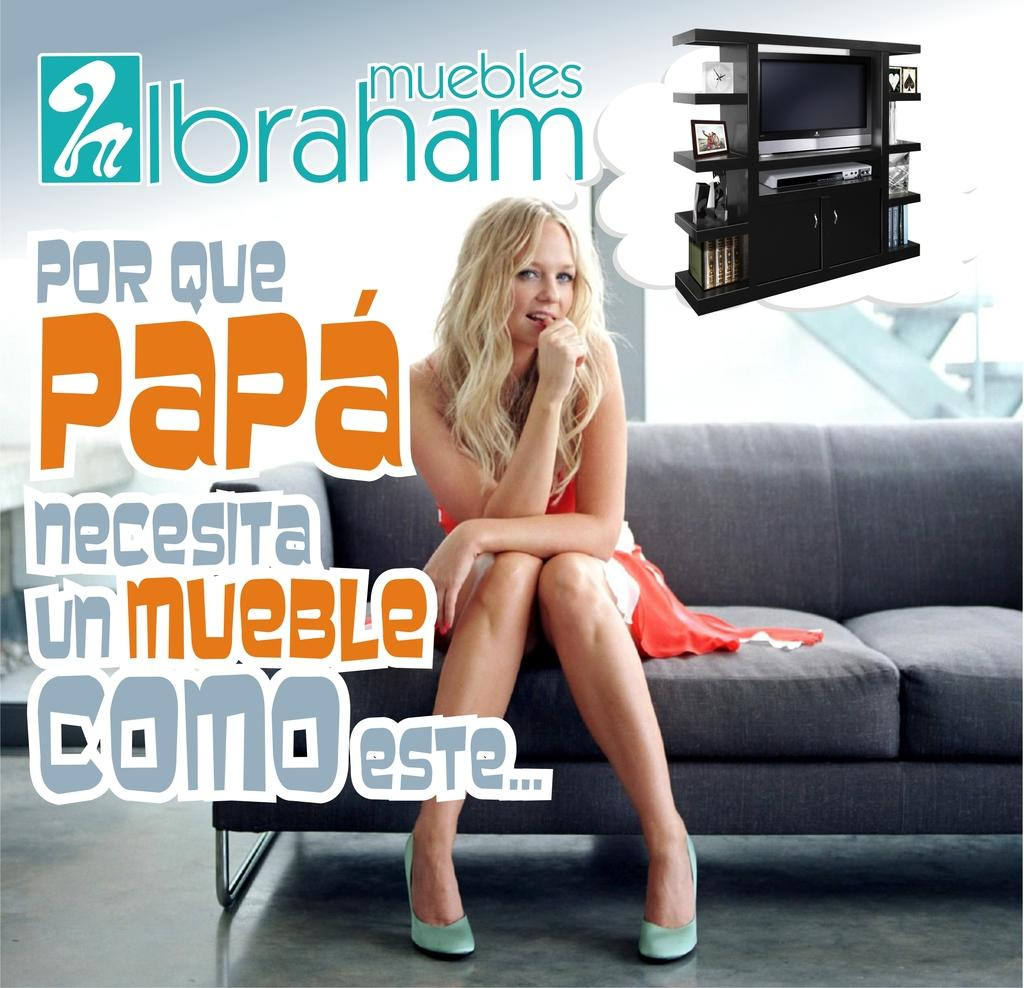Provide a one-sentence caption for the provided image. The ads with a young woman sitting on the sofa is made for Muebles Ibraham. 